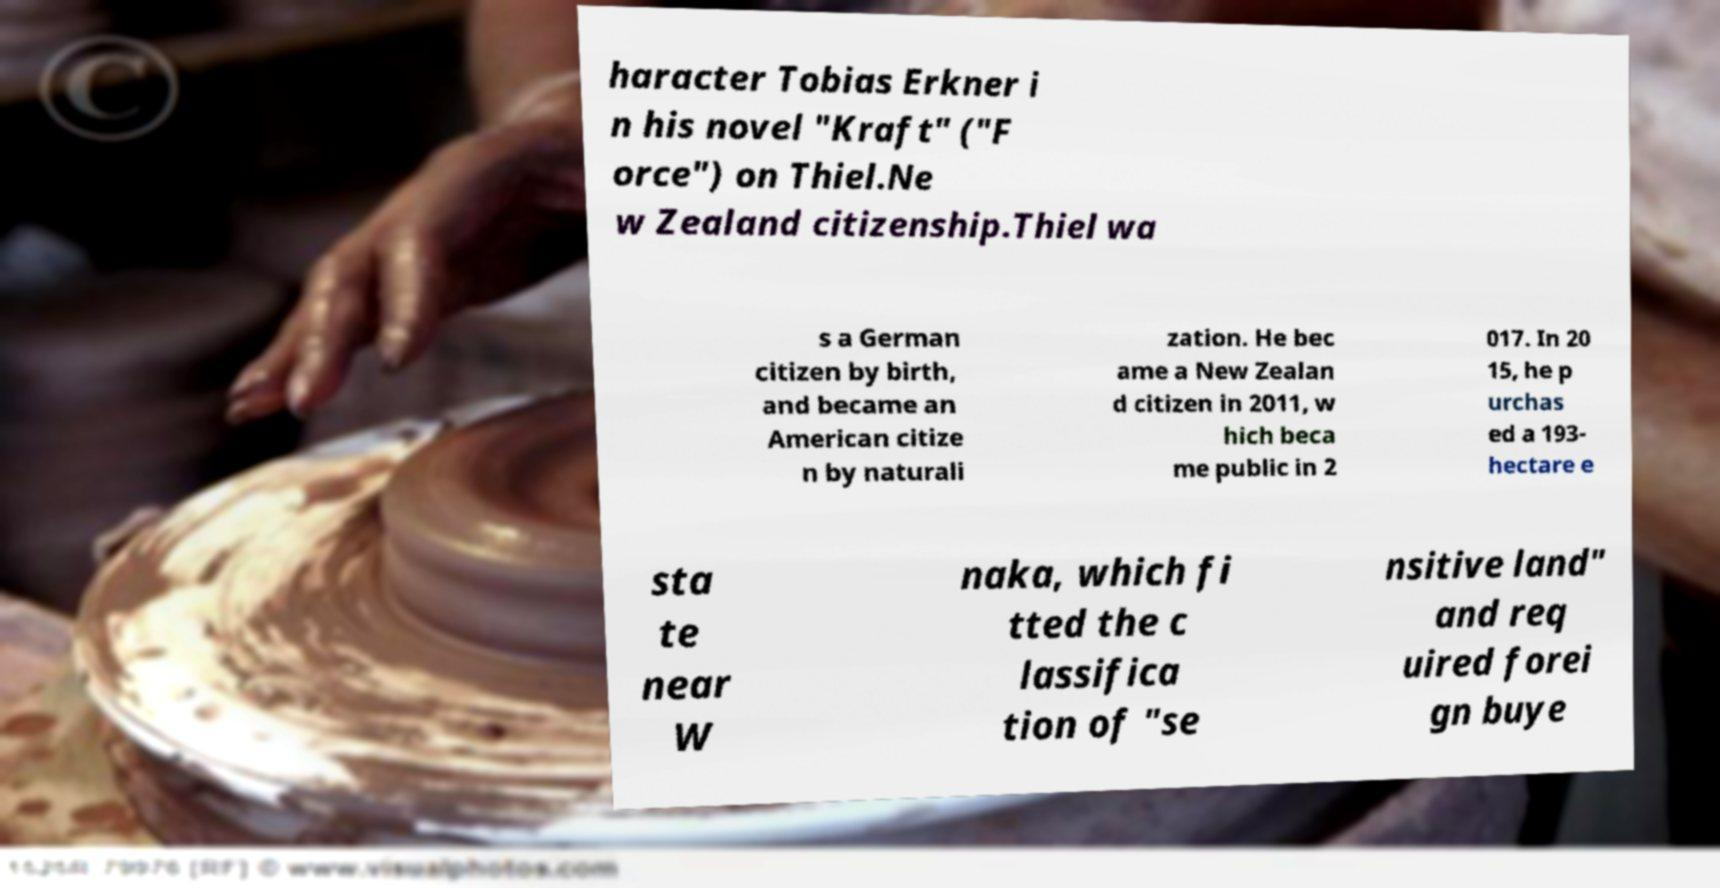Please identify and transcribe the text found in this image. haracter Tobias Erkner i n his novel "Kraft" ("F orce") on Thiel.Ne w Zealand citizenship.Thiel wa s a German citizen by birth, and became an American citize n by naturali zation. He bec ame a New Zealan d citizen in 2011, w hich beca me public in 2 017. In 20 15, he p urchas ed a 193- hectare e sta te near W naka, which fi tted the c lassifica tion of "se nsitive land" and req uired forei gn buye 